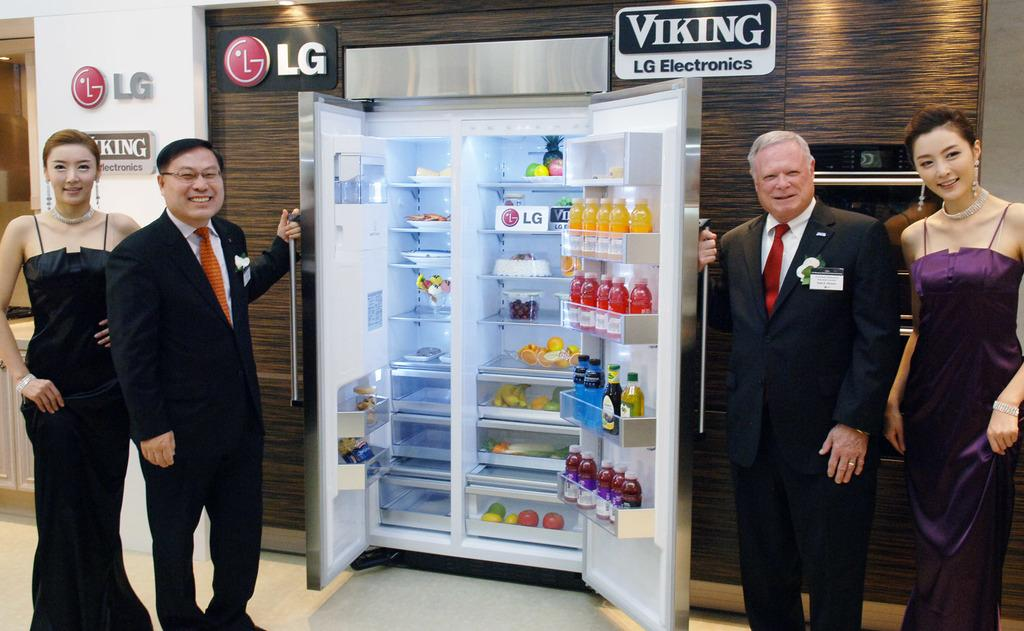<image>
Provide a brief description of the given image. An ad for Viking and LG electronics showing a huge refrigerator. 